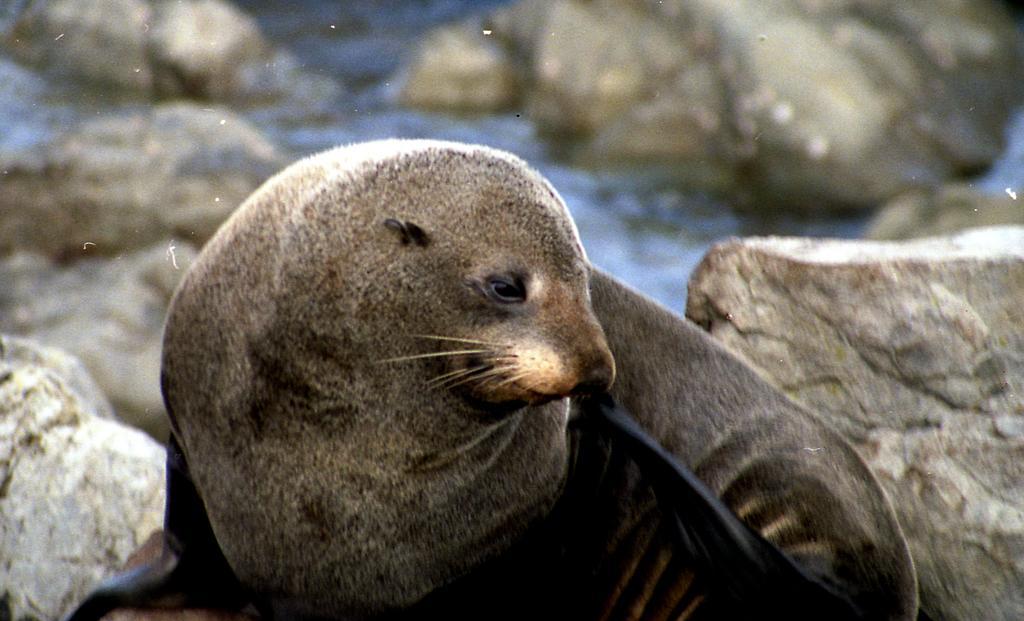Describe this image in one or two sentences. In the foreground of the picture there is a seal. In the background there are stones and water. 